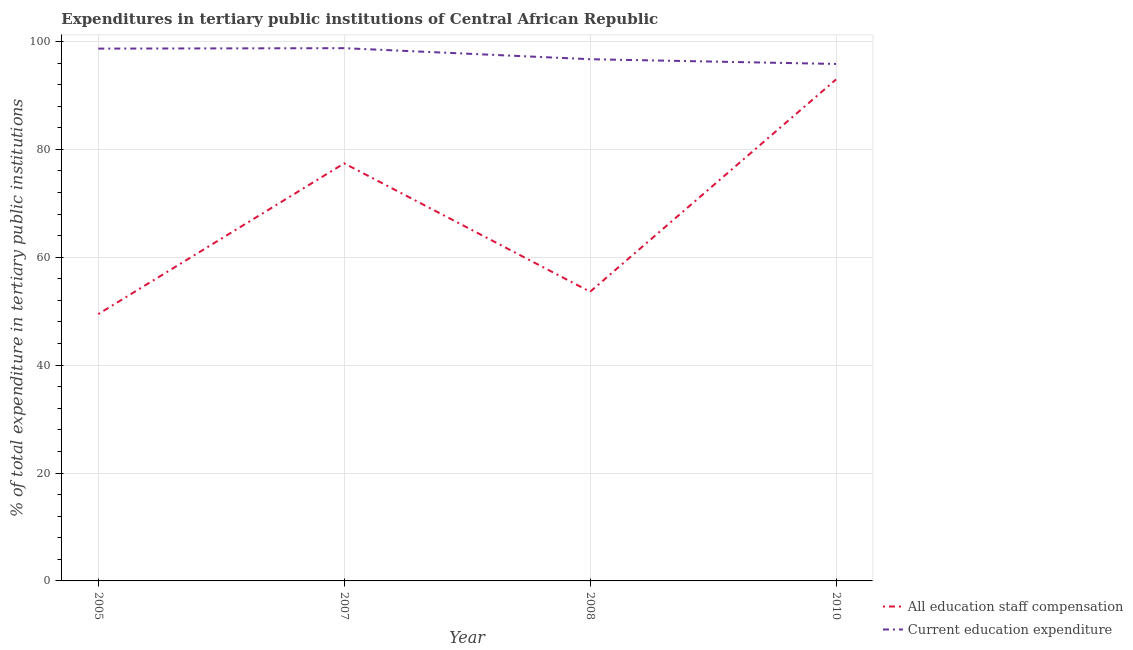Is the number of lines equal to the number of legend labels?
Make the answer very short. Yes. What is the expenditure in education in 2008?
Keep it short and to the point. 96.71. Across all years, what is the maximum expenditure in staff compensation?
Your response must be concise. 92.97. Across all years, what is the minimum expenditure in staff compensation?
Your answer should be very brief. 49.46. In which year was the expenditure in education maximum?
Offer a very short reply. 2007. What is the total expenditure in staff compensation in the graph?
Provide a short and direct response. 273.45. What is the difference between the expenditure in education in 2007 and that in 2008?
Provide a short and direct response. 2.05. What is the difference between the expenditure in education in 2007 and the expenditure in staff compensation in 2008?
Your response must be concise. 45.15. What is the average expenditure in staff compensation per year?
Keep it short and to the point. 68.36. In the year 2005, what is the difference between the expenditure in education and expenditure in staff compensation?
Your response must be concise. 49.21. In how many years, is the expenditure in education greater than 84 %?
Your response must be concise. 4. What is the ratio of the expenditure in staff compensation in 2005 to that in 2010?
Your response must be concise. 0.53. Is the expenditure in staff compensation in 2007 less than that in 2010?
Provide a short and direct response. Yes. What is the difference between the highest and the second highest expenditure in staff compensation?
Provide a short and direct response. 15.56. What is the difference between the highest and the lowest expenditure in staff compensation?
Provide a succinct answer. 43.51. In how many years, is the expenditure in education greater than the average expenditure in education taken over all years?
Provide a short and direct response. 2. Is the expenditure in staff compensation strictly greater than the expenditure in education over the years?
Ensure brevity in your answer.  No. Is the expenditure in education strictly less than the expenditure in staff compensation over the years?
Provide a short and direct response. No. How many lines are there?
Give a very brief answer. 2. How many years are there in the graph?
Your answer should be very brief. 4. What is the difference between two consecutive major ticks on the Y-axis?
Ensure brevity in your answer.  20. Does the graph contain any zero values?
Your answer should be compact. No. Does the graph contain grids?
Your answer should be compact. Yes. What is the title of the graph?
Ensure brevity in your answer.  Expenditures in tertiary public institutions of Central African Republic. What is the label or title of the X-axis?
Make the answer very short. Year. What is the label or title of the Y-axis?
Give a very brief answer. % of total expenditure in tertiary public institutions. What is the % of total expenditure in tertiary public institutions of All education staff compensation in 2005?
Give a very brief answer. 49.46. What is the % of total expenditure in tertiary public institutions in Current education expenditure in 2005?
Keep it short and to the point. 98.68. What is the % of total expenditure in tertiary public institutions in All education staff compensation in 2007?
Ensure brevity in your answer.  77.41. What is the % of total expenditure in tertiary public institutions in Current education expenditure in 2007?
Your response must be concise. 98.76. What is the % of total expenditure in tertiary public institutions of All education staff compensation in 2008?
Keep it short and to the point. 53.61. What is the % of total expenditure in tertiary public institutions in Current education expenditure in 2008?
Your answer should be compact. 96.71. What is the % of total expenditure in tertiary public institutions in All education staff compensation in 2010?
Provide a succinct answer. 92.97. What is the % of total expenditure in tertiary public institutions in Current education expenditure in 2010?
Keep it short and to the point. 95.83. Across all years, what is the maximum % of total expenditure in tertiary public institutions in All education staff compensation?
Provide a short and direct response. 92.97. Across all years, what is the maximum % of total expenditure in tertiary public institutions in Current education expenditure?
Provide a short and direct response. 98.76. Across all years, what is the minimum % of total expenditure in tertiary public institutions in All education staff compensation?
Ensure brevity in your answer.  49.46. Across all years, what is the minimum % of total expenditure in tertiary public institutions of Current education expenditure?
Your answer should be compact. 95.83. What is the total % of total expenditure in tertiary public institutions in All education staff compensation in the graph?
Keep it short and to the point. 273.45. What is the total % of total expenditure in tertiary public institutions of Current education expenditure in the graph?
Provide a succinct answer. 389.98. What is the difference between the % of total expenditure in tertiary public institutions of All education staff compensation in 2005 and that in 2007?
Offer a very short reply. -27.94. What is the difference between the % of total expenditure in tertiary public institutions of Current education expenditure in 2005 and that in 2007?
Ensure brevity in your answer.  -0.08. What is the difference between the % of total expenditure in tertiary public institutions of All education staff compensation in 2005 and that in 2008?
Give a very brief answer. -4.14. What is the difference between the % of total expenditure in tertiary public institutions in Current education expenditure in 2005 and that in 2008?
Your response must be concise. 1.97. What is the difference between the % of total expenditure in tertiary public institutions of All education staff compensation in 2005 and that in 2010?
Your response must be concise. -43.51. What is the difference between the % of total expenditure in tertiary public institutions of Current education expenditure in 2005 and that in 2010?
Your answer should be very brief. 2.84. What is the difference between the % of total expenditure in tertiary public institutions of All education staff compensation in 2007 and that in 2008?
Provide a short and direct response. 23.8. What is the difference between the % of total expenditure in tertiary public institutions of Current education expenditure in 2007 and that in 2008?
Offer a terse response. 2.05. What is the difference between the % of total expenditure in tertiary public institutions in All education staff compensation in 2007 and that in 2010?
Give a very brief answer. -15.56. What is the difference between the % of total expenditure in tertiary public institutions in Current education expenditure in 2007 and that in 2010?
Provide a succinct answer. 2.93. What is the difference between the % of total expenditure in tertiary public institutions of All education staff compensation in 2008 and that in 2010?
Provide a succinct answer. -39.36. What is the difference between the % of total expenditure in tertiary public institutions of Current education expenditure in 2008 and that in 2010?
Ensure brevity in your answer.  0.88. What is the difference between the % of total expenditure in tertiary public institutions in All education staff compensation in 2005 and the % of total expenditure in tertiary public institutions in Current education expenditure in 2007?
Give a very brief answer. -49.3. What is the difference between the % of total expenditure in tertiary public institutions of All education staff compensation in 2005 and the % of total expenditure in tertiary public institutions of Current education expenditure in 2008?
Give a very brief answer. -47.25. What is the difference between the % of total expenditure in tertiary public institutions in All education staff compensation in 2005 and the % of total expenditure in tertiary public institutions in Current education expenditure in 2010?
Your answer should be compact. -46.37. What is the difference between the % of total expenditure in tertiary public institutions in All education staff compensation in 2007 and the % of total expenditure in tertiary public institutions in Current education expenditure in 2008?
Ensure brevity in your answer.  -19.3. What is the difference between the % of total expenditure in tertiary public institutions of All education staff compensation in 2007 and the % of total expenditure in tertiary public institutions of Current education expenditure in 2010?
Your answer should be compact. -18.42. What is the difference between the % of total expenditure in tertiary public institutions of All education staff compensation in 2008 and the % of total expenditure in tertiary public institutions of Current education expenditure in 2010?
Your response must be concise. -42.23. What is the average % of total expenditure in tertiary public institutions in All education staff compensation per year?
Provide a short and direct response. 68.36. What is the average % of total expenditure in tertiary public institutions of Current education expenditure per year?
Provide a short and direct response. 97.49. In the year 2005, what is the difference between the % of total expenditure in tertiary public institutions in All education staff compensation and % of total expenditure in tertiary public institutions in Current education expenditure?
Provide a succinct answer. -49.21. In the year 2007, what is the difference between the % of total expenditure in tertiary public institutions of All education staff compensation and % of total expenditure in tertiary public institutions of Current education expenditure?
Provide a succinct answer. -21.35. In the year 2008, what is the difference between the % of total expenditure in tertiary public institutions in All education staff compensation and % of total expenditure in tertiary public institutions in Current education expenditure?
Your response must be concise. -43.1. In the year 2010, what is the difference between the % of total expenditure in tertiary public institutions of All education staff compensation and % of total expenditure in tertiary public institutions of Current education expenditure?
Offer a terse response. -2.86. What is the ratio of the % of total expenditure in tertiary public institutions in All education staff compensation in 2005 to that in 2007?
Your answer should be very brief. 0.64. What is the ratio of the % of total expenditure in tertiary public institutions of Current education expenditure in 2005 to that in 2007?
Offer a very short reply. 1. What is the ratio of the % of total expenditure in tertiary public institutions of All education staff compensation in 2005 to that in 2008?
Ensure brevity in your answer.  0.92. What is the ratio of the % of total expenditure in tertiary public institutions of Current education expenditure in 2005 to that in 2008?
Provide a short and direct response. 1.02. What is the ratio of the % of total expenditure in tertiary public institutions of All education staff compensation in 2005 to that in 2010?
Give a very brief answer. 0.53. What is the ratio of the % of total expenditure in tertiary public institutions of Current education expenditure in 2005 to that in 2010?
Your answer should be very brief. 1.03. What is the ratio of the % of total expenditure in tertiary public institutions of All education staff compensation in 2007 to that in 2008?
Offer a terse response. 1.44. What is the ratio of the % of total expenditure in tertiary public institutions of Current education expenditure in 2007 to that in 2008?
Ensure brevity in your answer.  1.02. What is the ratio of the % of total expenditure in tertiary public institutions of All education staff compensation in 2007 to that in 2010?
Provide a succinct answer. 0.83. What is the ratio of the % of total expenditure in tertiary public institutions of Current education expenditure in 2007 to that in 2010?
Make the answer very short. 1.03. What is the ratio of the % of total expenditure in tertiary public institutions in All education staff compensation in 2008 to that in 2010?
Offer a very short reply. 0.58. What is the ratio of the % of total expenditure in tertiary public institutions in Current education expenditure in 2008 to that in 2010?
Provide a short and direct response. 1.01. What is the difference between the highest and the second highest % of total expenditure in tertiary public institutions of All education staff compensation?
Provide a short and direct response. 15.56. What is the difference between the highest and the second highest % of total expenditure in tertiary public institutions in Current education expenditure?
Offer a very short reply. 0.08. What is the difference between the highest and the lowest % of total expenditure in tertiary public institutions of All education staff compensation?
Ensure brevity in your answer.  43.51. What is the difference between the highest and the lowest % of total expenditure in tertiary public institutions of Current education expenditure?
Your answer should be compact. 2.93. 